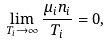<formula> <loc_0><loc_0><loc_500><loc_500>\lim _ { T _ { i } \to \infty } \frac { \mu _ { i } n _ { i } } { T _ { i } } = 0 ,</formula> 